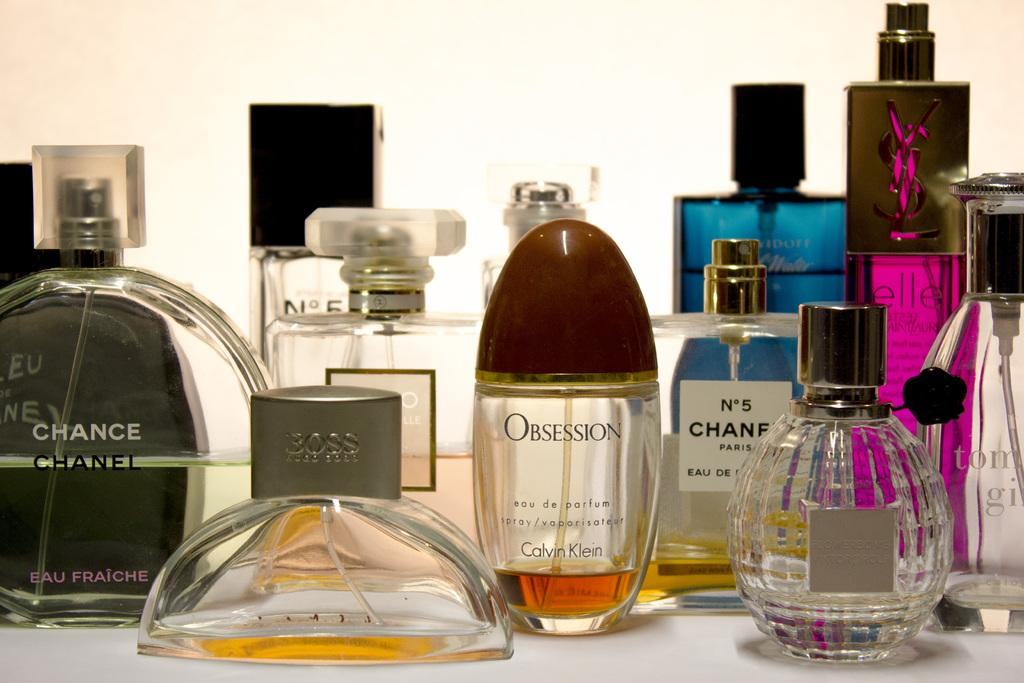<image>
Write a terse but informative summary of the picture. a cologne that has obsession written on it 